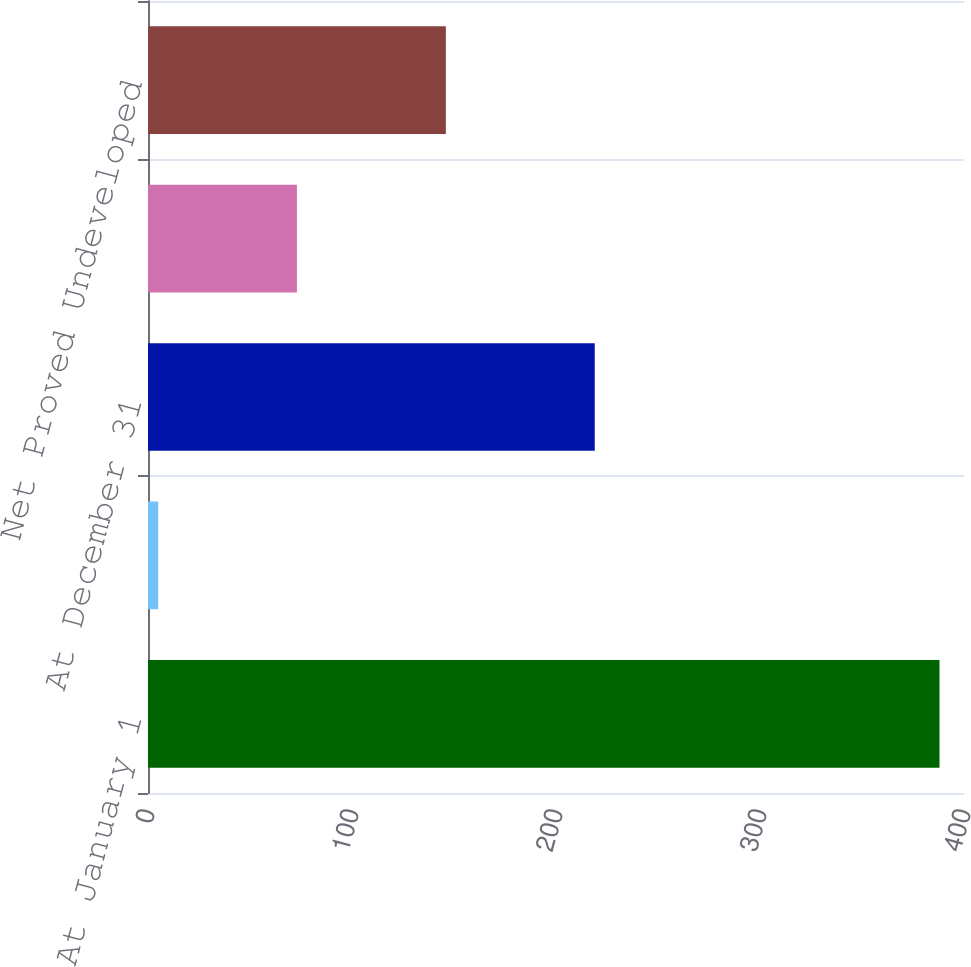<chart> <loc_0><loc_0><loc_500><loc_500><bar_chart><fcel>At January 1<fcel>Production<fcel>At December 31<fcel>Net Proved Developed Reserves<fcel>Net Proved Undeveloped<nl><fcel>388<fcel>5<fcel>219<fcel>73<fcel>146<nl></chart> 